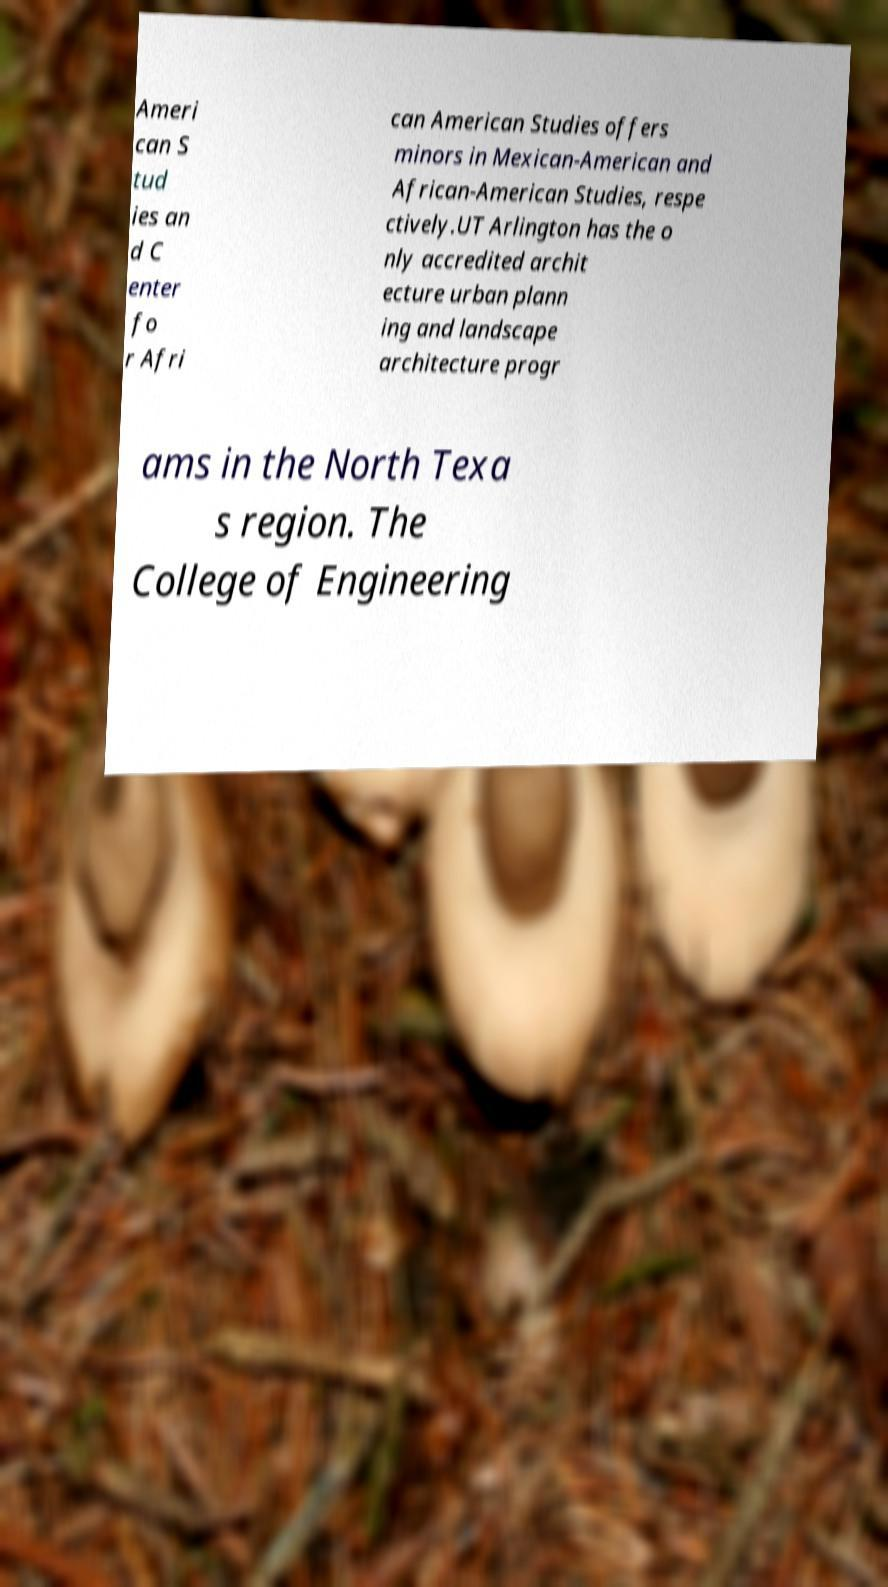For documentation purposes, I need the text within this image transcribed. Could you provide that? Ameri can S tud ies an d C enter fo r Afri can American Studies offers minors in Mexican-American and African-American Studies, respe ctively.UT Arlington has the o nly accredited archit ecture urban plann ing and landscape architecture progr ams in the North Texa s region. The College of Engineering 